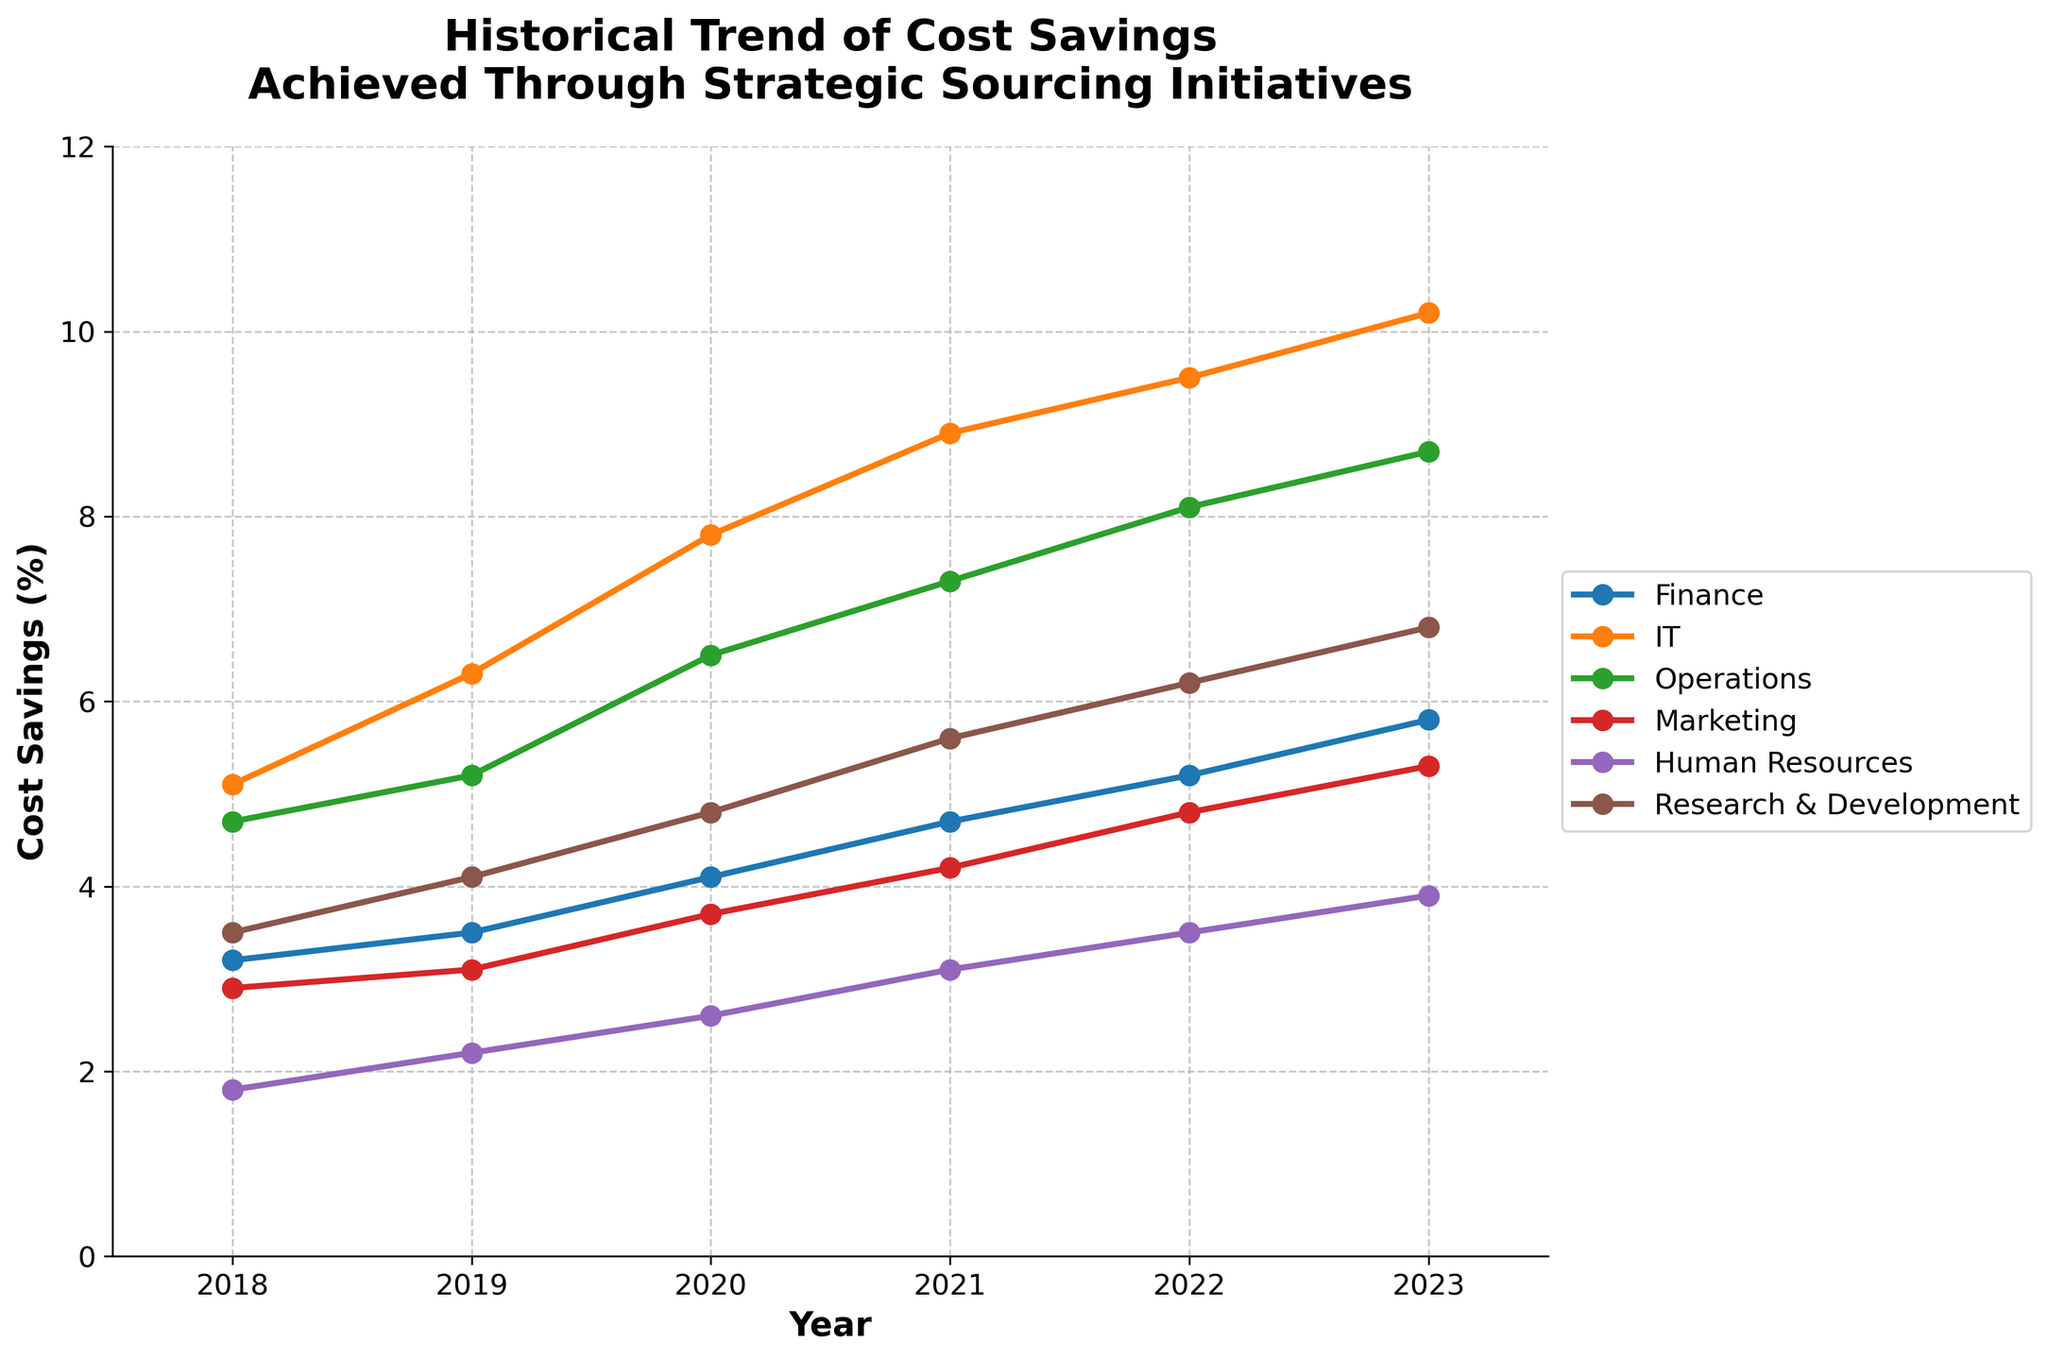What was the cost savings percentage achieved by the IT department in 2021? The IT department's cost savings percentage in 2021 can be directly read from the line corresponding to the IT department in the line chart.
Answer: 8.9% Which department had the highest cost savings percentage in 2023? By identifying the highest point among all the lines on the plot for 2023, we can see that the IT department achieved the highest cost savings.
Answer: IT How did the cost savings of the Finance department change from 2018 to 2023? To find the change in cost savings for the Finance department, subtract the cost savings percentage of 2018 from that of 2023. (5.8% - 3.2%)
Answer: 2.6% Compare the cost savings trends for the Operations and Marketing departments. Which department saw a more significant increase? Looking at the charts for Operations and Marketing, the Operations department increased from 4.7% in 2018 to 8.7% in 2023, whereas Marketing increased from 2.9% in 2018 to 5.3% in 2023. The difference for Operations is 4%, and for Marketing, it is 2.4%.
Answer: Operations What is the average cost savings percentage achieved by the Research & Development department from 2018 to 2023? Find the average by summing the cost savings percentages for Research & Development from each year (3.5% + 4.1% + 4.8% + 5.6% + 6.2% + 6.8%) and divide by the number of years (6). (3.5 + 4.1 + 4.8 + 5.6 + 6.2 + 6.8) / 6 = 5.1667%
Answer: 5.17% Which two departments had the closest cost savings percentage in 2022? Compare the values for all departments in 2022. The Human Resources department had 3.5%, and the Finance department had 5.2%. These two values are the closest to each other among all departments in 2022.
Answer: Finance and Human Resources What is the overall trend in cost savings for the Human Resources department? By observing the line representing Human Resources from 2018 to 2023, the graph shows an upward trend from 1.8% in 2018 to 3.9% in 2023.
Answer: Upward How much more cost savings did the Operations department achieve compared to the Marketing department in 2020? Find the difference between the cost savings percentages for Operations and Marketing in 2020. (6.5% - 3.7%)
Answer: 2.8% What was the cumulative increase in cost savings for the Research & Development department from 2018 through 2021? Sum the yearly increases from 2018 to 2021 for the Research & Development department: (4.1% - 3.5%) = 0.6%, (4.8% - 4.1%) = 0.7%, (5.6% - 4.8%) = 0.8%. Then sum these increases (0.6 + 0.7 + 0.8).
Answer: 2.1% Which department showed the least improvement in cost savings from 2019 to 2020? Calculate the difference in percentages between 2019 and 2020 for all departments and identify the smallest difference. Human Resources increased by 0.4% from 2.2% to 2.6%, which is the smallest improvement.
Answer: Human Resources 